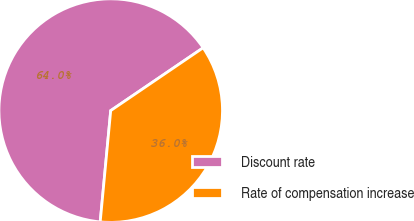Convert chart to OTSL. <chart><loc_0><loc_0><loc_500><loc_500><pie_chart><fcel>Discount rate<fcel>Rate of compensation increase<nl><fcel>64.0%<fcel>36.0%<nl></chart> 